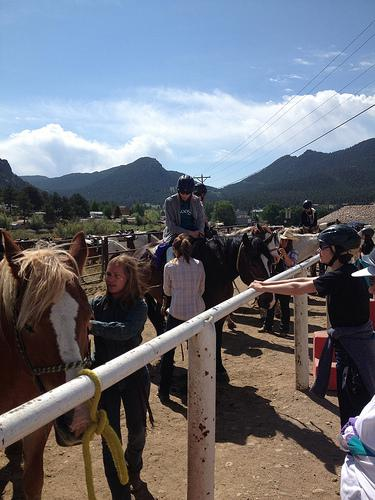Question: what kind of animal is in the photo?
Choices:
A. Horse.
B. Lion.
C. Dog.
D. Cat.
Answer with the letter. Answer: A Question: where is this taking place?
Choices:
A. Mountain.
B. Forest.
C. Ranch.
D. Golf course.
Answer with the letter. Answer: C Question: what is the white structure in the foreground of the photo?
Choices:
A. Fence.
B. House.
C. Shed.
D. Barn.
Answer with the letter. Answer: A Question: how many helmets are visible in the photo?
Choices:
A. Two.
B. One.
C. Three.
D. Four.
Answer with the letter. Answer: C Question: what are the structures in the background of the photo?
Choices:
A. Mountains.
B. Warehouses.
C. Garages.
D. Homes.
Answer with the letter. Answer: A 